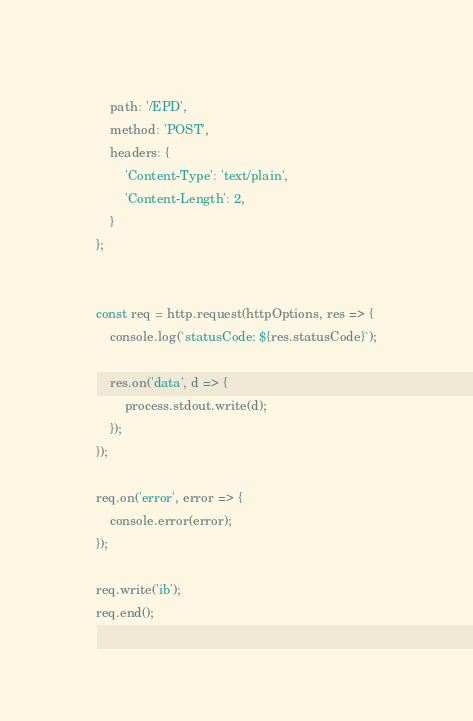<code> <loc_0><loc_0><loc_500><loc_500><_JavaScript_>	path: '/EPD',
	method: 'POST',
	headers: {
		'Content-Type': 'text/plain',
		'Content-Length': 2,
	}
};


const req = http.request(httpOptions, res => {
	console.log(`statusCode: ${res.statusCode}`);

	res.on('data', d => {
		process.stdout.write(d);
	});
});

req.on('error', error => {
	console.error(error);
});

req.write('ib');
req.end();
</code> 